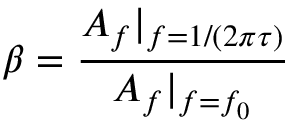Convert formula to latex. <formula><loc_0><loc_0><loc_500><loc_500>\beta = \frac { A _ { f } | _ { f = 1 / ( 2 \pi \tau ) } } { A _ { f } | _ { f = f _ { 0 } } }</formula> 